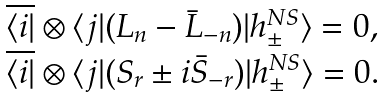Convert formula to latex. <formula><loc_0><loc_0><loc_500><loc_500>\begin{array} { l } \overline { \langle i | } \otimes \langle j | ( L _ { n } - \bar { L } _ { - n } ) | h _ { \pm } ^ { N S } \rangle = 0 , \\ \overline { \langle i | } \otimes \langle j | ( S _ { r } \pm i \bar { S } _ { - r } ) | h _ { \pm } ^ { N S } \rangle = 0 . \end{array}</formula> 